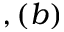<formula> <loc_0><loc_0><loc_500><loc_500>, ( b )</formula> 